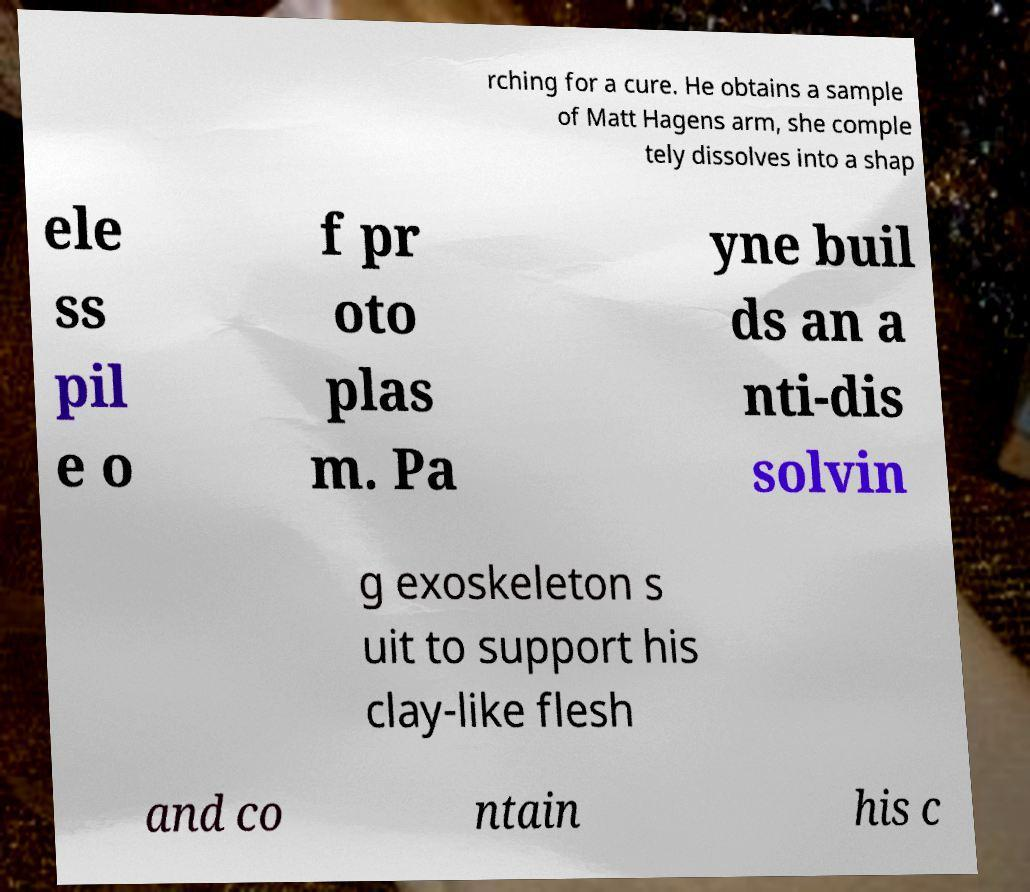I need the written content from this picture converted into text. Can you do that? rching for a cure. He obtains a sample of Matt Hagens arm, she comple tely dissolves into a shap ele ss pil e o f pr oto plas m. Pa yne buil ds an a nti-dis solvin g exoskeleton s uit to support his clay-like flesh and co ntain his c 